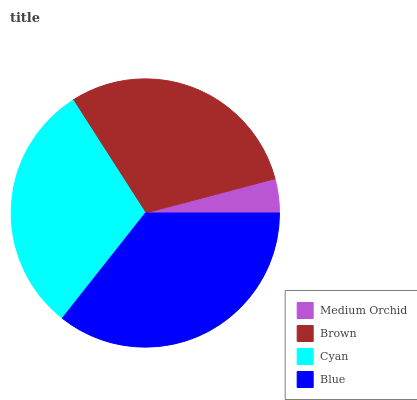Is Medium Orchid the minimum?
Answer yes or no. Yes. Is Blue the maximum?
Answer yes or no. Yes. Is Brown the minimum?
Answer yes or no. No. Is Brown the maximum?
Answer yes or no. No. Is Brown greater than Medium Orchid?
Answer yes or no. Yes. Is Medium Orchid less than Brown?
Answer yes or no. Yes. Is Medium Orchid greater than Brown?
Answer yes or no. No. Is Brown less than Medium Orchid?
Answer yes or no. No. Is Cyan the high median?
Answer yes or no. Yes. Is Brown the low median?
Answer yes or no. Yes. Is Blue the high median?
Answer yes or no. No. Is Blue the low median?
Answer yes or no. No. 